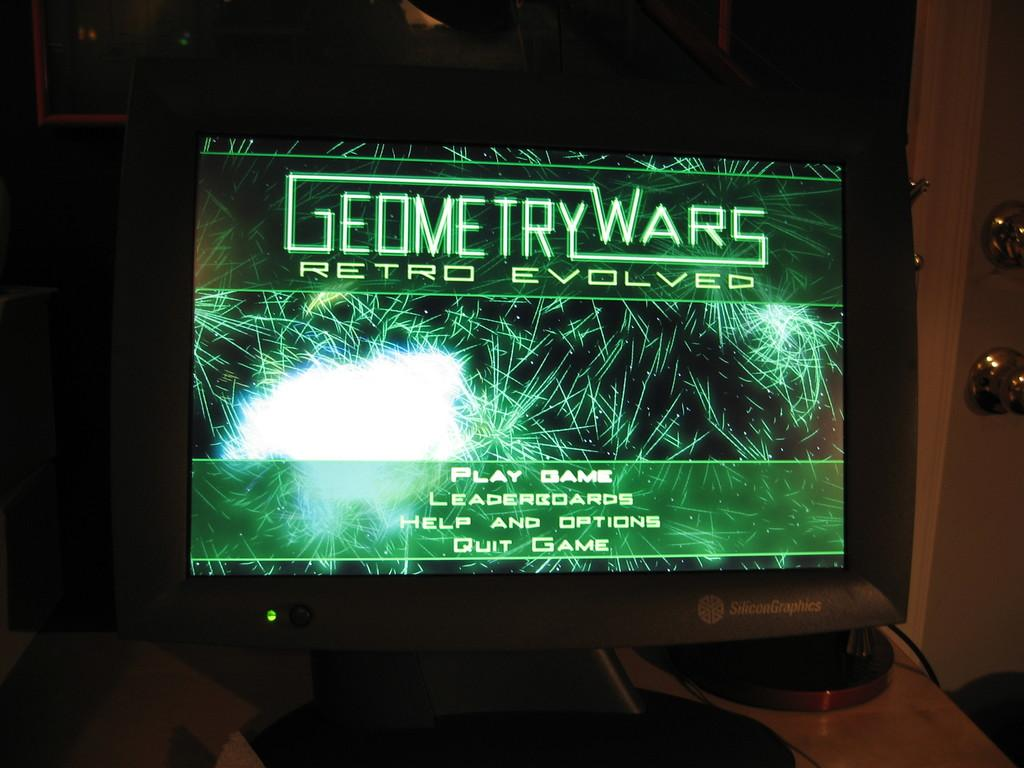Provide a one-sentence caption for the provided image. A Geometry Wars Retro Evolved game on a video screen. 